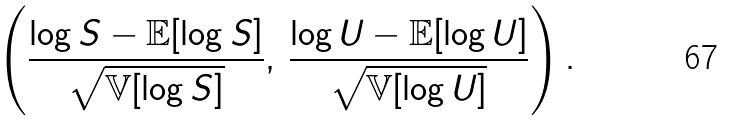<formula> <loc_0><loc_0><loc_500><loc_500>\left ( \frac { \log S - \mathbb { E } [ \log S ] } { \sqrt { \mathbb { V } [ \log S ] } } , \, \frac { \log U - \mathbb { E } [ \log U ] } { \sqrt { \mathbb { V } [ \log U ] } } \right ) .</formula> 